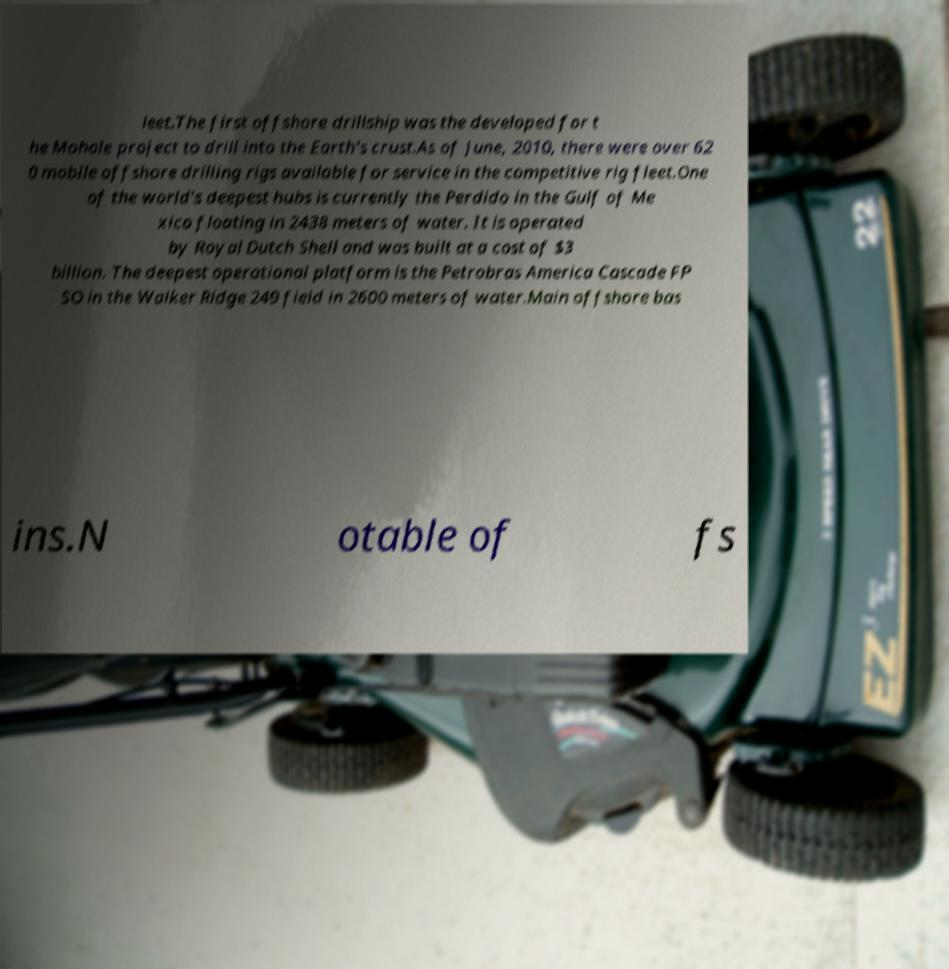There's text embedded in this image that I need extracted. Can you transcribe it verbatim? leet.The first offshore drillship was the developed for t he Mohole project to drill into the Earth's crust.As of June, 2010, there were over 62 0 mobile offshore drilling rigs available for service in the competitive rig fleet.One of the world's deepest hubs is currently the Perdido in the Gulf of Me xico floating in 2438 meters of water. It is operated by Royal Dutch Shell and was built at a cost of $3 billion. The deepest operational platform is the Petrobras America Cascade FP SO in the Walker Ridge 249 field in 2600 meters of water.Main offshore bas ins.N otable of fs 